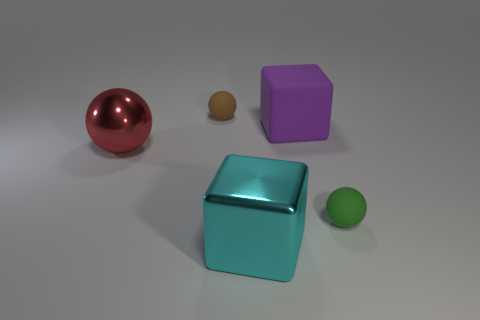Add 2 large red metallic objects. How many objects exist? 7 Subtract 2 balls. How many balls are left? 1 Subtract all red spheres. How many spheres are left? 2 Subtract all spheres. How many objects are left? 2 Subtract all red spheres. How many spheres are left? 2 Subtract all large red metal balls. Subtract all matte balls. How many objects are left? 2 Add 2 cubes. How many cubes are left? 4 Add 2 cylinders. How many cylinders exist? 2 Subtract 0 purple balls. How many objects are left? 5 Subtract all red cubes. Subtract all green spheres. How many cubes are left? 2 